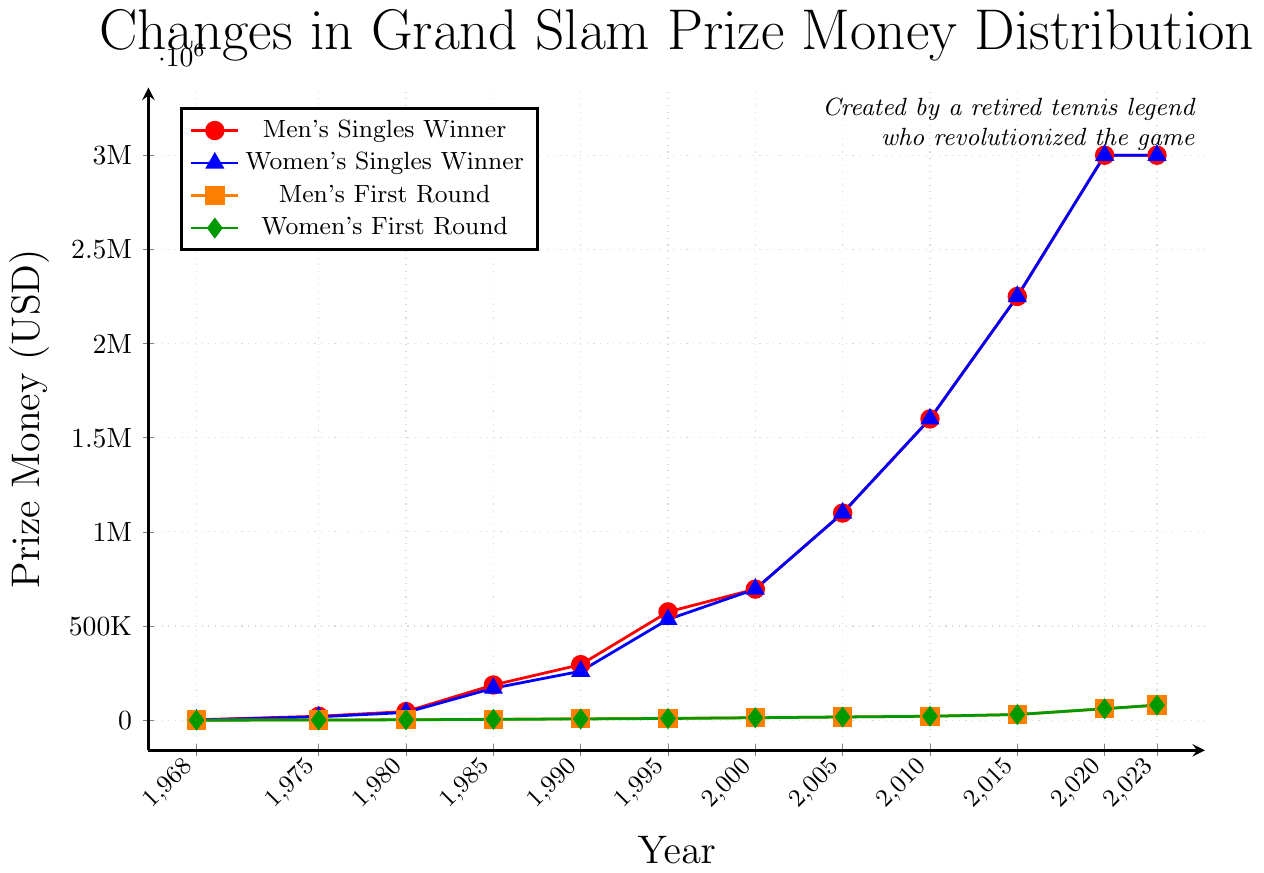What is the prize money for the Men's Singles Winner in 1990? The prize money for the Men's Singles Winner in 1990 is marked by a point on the red line. By locating the point for the year 1990 on the x-axis and the corresponding value on the y-axis, we see it is $295,000.
Answer: $295,000 In which year did the Men's Singles Winner's prize money first exceed $1,000,000? Look at the red line to determine when the prize money crosses the $1,000,000 mark on the y-axis. This occurs in the year 2005.
Answer: 2005 By how much did the Women's Singles Winner prize money increase from 1995 to 2000? Locate the points for the Women's Singles Winner prize money in 1995 and 2000 on the blue line. The value in 1995 is $535,000, and in 2000, it is $696,000. The increase is $696,000 - $535,000 = $161,000.
Answer: $161,000 Which category had the highest prize money in 2000? Compare the values for all categories in the year 2000. Both the Men's Singles Winner and Women's Singles Winner have the highest prize money at $696,000.
Answer: Men's & Women's Singles Winner How much more prize money did the Men's Singles Winner get compared to the Women's Singles Winner in 1968? Locate the prize money for the Men's Singles Winner ($2,000) and the Women's Singles Winner ($750) in 1968 and find the difference. $2,000 - $750 = $1,250.
Answer: $1,250 What is the trend in prize money for the Women's First Round from 1968 to 2023? Follow the green line from 1968 to 2023. The trend shows a consistent increase in prize money over the years.
Answer: Increasing Which year had the smallest gap between the prize money for Men's First Round and Women's First Round? Identify the points on the orange and green lines and calculate the gaps for each year. The smallest gap appears in 2000, where both had the same prize money ($13,000).
Answer: 2000 How much did the prize money for the Men’s First Round increase from 2020 to 2023? Locate the values for Men’s First Round in 2020 ($61,000) and 2023 ($80,000) on the orange line. The increase is $80,000 - $61,000 = $19,000.
Answer: $19,000 On average, by how much did the prize money for the Women’s Singles Winner increase per decade from 1968 to 2023? Calculate the increase between each decade point (1970, 1980, etc.) and divide by the number of those periods within 1968-2023. This is a complex calculation, yielding (Total Increase / Number of periods) approximately.
Answer: Approx. $245,000 per decade How does the prize money of the Men's and Women's Singles Winners compare in the mid-90s? Look at the values of prize money for both categories around 1995. Both the Men's and Women's Singles Winners have similar prize money with a slight lower value for the Women's winner, $575,000 vs. $535,000.
Answer: Men's slightly higher 